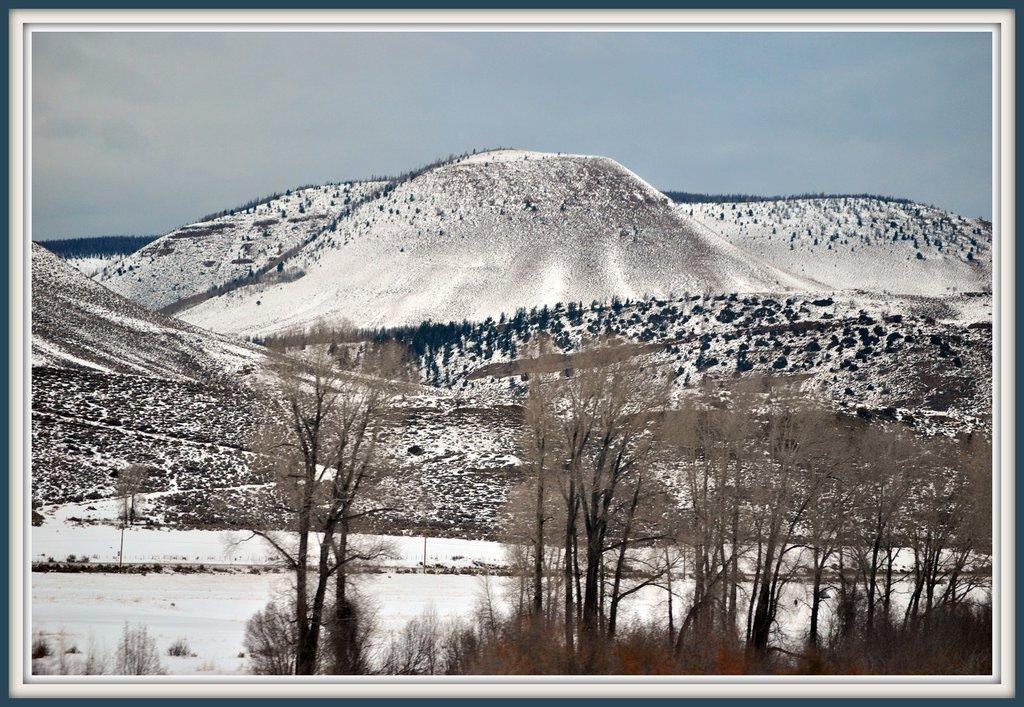What is depicted on the wall hanging in the image? The wall hanging contains mountains, trees, and sky with clouds. Can you describe the elements present in the wall hanging? The wall hanging contains mountains, trees, and sky with clouds. What type of soap is advertised on the wall hanging in the image? There is no soap advertised on the wall hanging in the image; it contains mountains, trees, and sky with clouds. 